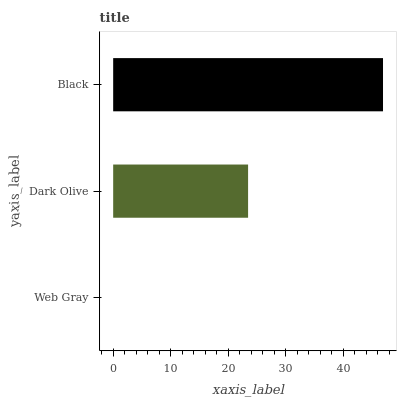Is Web Gray the minimum?
Answer yes or no. Yes. Is Black the maximum?
Answer yes or no. Yes. Is Dark Olive the minimum?
Answer yes or no. No. Is Dark Olive the maximum?
Answer yes or no. No. Is Dark Olive greater than Web Gray?
Answer yes or no. Yes. Is Web Gray less than Dark Olive?
Answer yes or no. Yes. Is Web Gray greater than Dark Olive?
Answer yes or no. No. Is Dark Olive less than Web Gray?
Answer yes or no. No. Is Dark Olive the high median?
Answer yes or no. Yes. Is Dark Olive the low median?
Answer yes or no. Yes. Is Web Gray the high median?
Answer yes or no. No. Is Black the low median?
Answer yes or no. No. 